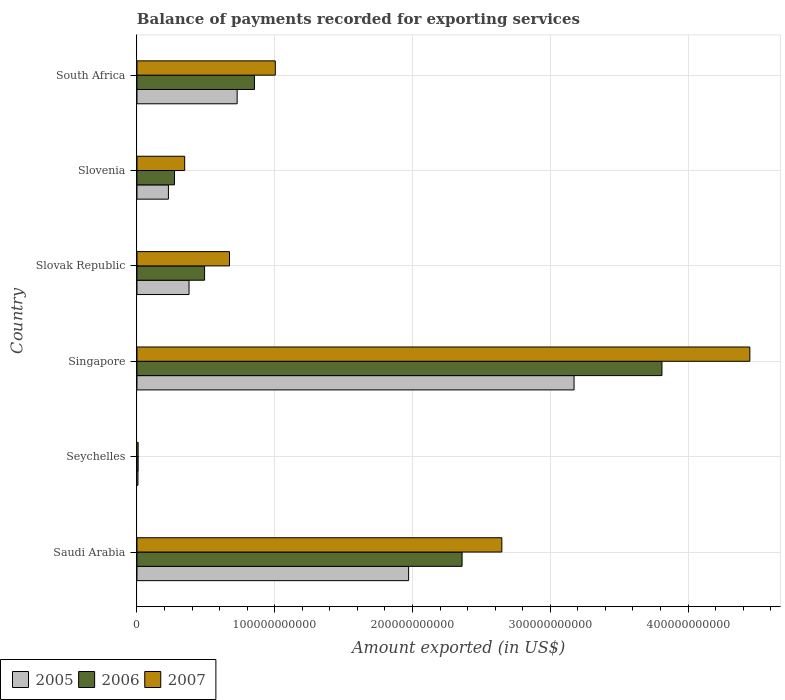How many different coloured bars are there?
Offer a very short reply. 3. How many groups of bars are there?
Keep it short and to the point. 6. How many bars are there on the 5th tick from the bottom?
Provide a short and direct response. 3. What is the label of the 3rd group of bars from the top?
Provide a succinct answer. Slovak Republic. In how many cases, is the number of bars for a given country not equal to the number of legend labels?
Your answer should be compact. 0. What is the amount exported in 2005 in South Africa?
Offer a terse response. 7.27e+1. Across all countries, what is the maximum amount exported in 2006?
Your answer should be compact. 3.81e+11. Across all countries, what is the minimum amount exported in 2005?
Ensure brevity in your answer.  7.29e+08. In which country was the amount exported in 2006 maximum?
Your answer should be compact. Singapore. In which country was the amount exported in 2005 minimum?
Ensure brevity in your answer.  Seychelles. What is the total amount exported in 2006 in the graph?
Offer a terse response. 7.79e+11. What is the difference between the amount exported in 2005 in Seychelles and that in Slovak Republic?
Offer a very short reply. -3.71e+1. What is the difference between the amount exported in 2005 in Saudi Arabia and the amount exported in 2006 in South Africa?
Provide a short and direct response. 1.12e+11. What is the average amount exported in 2006 per country?
Provide a succinct answer. 1.30e+11. What is the difference between the amount exported in 2005 and amount exported in 2007 in Saudi Arabia?
Your answer should be compact. -6.77e+1. What is the ratio of the amount exported in 2005 in Seychelles to that in South Africa?
Provide a short and direct response. 0.01. Is the difference between the amount exported in 2005 in Saudi Arabia and Slovenia greater than the difference between the amount exported in 2007 in Saudi Arabia and Slovenia?
Ensure brevity in your answer.  No. What is the difference between the highest and the second highest amount exported in 2007?
Your response must be concise. 1.80e+11. What is the difference between the highest and the lowest amount exported in 2006?
Provide a short and direct response. 3.80e+11. In how many countries, is the amount exported in 2006 greater than the average amount exported in 2006 taken over all countries?
Ensure brevity in your answer.  2. Is the sum of the amount exported in 2005 in Saudi Arabia and Singapore greater than the maximum amount exported in 2007 across all countries?
Offer a very short reply. Yes. What does the 3rd bar from the top in Slovak Republic represents?
Ensure brevity in your answer.  2005. How many countries are there in the graph?
Your answer should be very brief. 6. What is the difference between two consecutive major ticks on the X-axis?
Provide a succinct answer. 1.00e+11. Are the values on the major ticks of X-axis written in scientific E-notation?
Offer a very short reply. No. Does the graph contain any zero values?
Make the answer very short. No. Does the graph contain grids?
Give a very brief answer. Yes. Where does the legend appear in the graph?
Your response must be concise. Bottom left. How are the legend labels stacked?
Your response must be concise. Horizontal. What is the title of the graph?
Your answer should be compact. Balance of payments recorded for exporting services. Does "2004" appear as one of the legend labels in the graph?
Keep it short and to the point. No. What is the label or title of the X-axis?
Your response must be concise. Amount exported (in US$). What is the label or title of the Y-axis?
Offer a terse response. Country. What is the Amount exported (in US$) in 2005 in Saudi Arabia?
Offer a very short reply. 1.97e+11. What is the Amount exported (in US$) of 2006 in Saudi Arabia?
Your answer should be very brief. 2.36e+11. What is the Amount exported (in US$) of 2007 in Saudi Arabia?
Make the answer very short. 2.65e+11. What is the Amount exported (in US$) in 2005 in Seychelles?
Ensure brevity in your answer.  7.29e+08. What is the Amount exported (in US$) in 2006 in Seychelles?
Ensure brevity in your answer.  8.61e+08. What is the Amount exported (in US$) of 2007 in Seychelles?
Ensure brevity in your answer.  8.57e+08. What is the Amount exported (in US$) of 2005 in Singapore?
Ensure brevity in your answer.  3.17e+11. What is the Amount exported (in US$) of 2006 in Singapore?
Offer a terse response. 3.81e+11. What is the Amount exported (in US$) of 2007 in Singapore?
Make the answer very short. 4.45e+11. What is the Amount exported (in US$) in 2005 in Slovak Republic?
Offer a terse response. 3.78e+1. What is the Amount exported (in US$) in 2006 in Slovak Republic?
Your answer should be compact. 4.91e+1. What is the Amount exported (in US$) of 2007 in Slovak Republic?
Offer a terse response. 6.72e+1. What is the Amount exported (in US$) in 2005 in Slovenia?
Provide a short and direct response. 2.28e+1. What is the Amount exported (in US$) of 2006 in Slovenia?
Your answer should be very brief. 2.72e+1. What is the Amount exported (in US$) of 2007 in Slovenia?
Ensure brevity in your answer.  3.46e+1. What is the Amount exported (in US$) of 2005 in South Africa?
Ensure brevity in your answer.  7.27e+1. What is the Amount exported (in US$) of 2006 in South Africa?
Provide a short and direct response. 8.53e+1. What is the Amount exported (in US$) in 2007 in South Africa?
Your answer should be compact. 1.00e+11. Across all countries, what is the maximum Amount exported (in US$) in 2005?
Make the answer very short. 3.17e+11. Across all countries, what is the maximum Amount exported (in US$) in 2006?
Give a very brief answer. 3.81e+11. Across all countries, what is the maximum Amount exported (in US$) of 2007?
Ensure brevity in your answer.  4.45e+11. Across all countries, what is the minimum Amount exported (in US$) in 2005?
Provide a succinct answer. 7.29e+08. Across all countries, what is the minimum Amount exported (in US$) of 2006?
Your answer should be very brief. 8.61e+08. Across all countries, what is the minimum Amount exported (in US$) in 2007?
Ensure brevity in your answer.  8.57e+08. What is the total Amount exported (in US$) in 2005 in the graph?
Ensure brevity in your answer.  6.49e+11. What is the total Amount exported (in US$) of 2006 in the graph?
Offer a very short reply. 7.79e+11. What is the total Amount exported (in US$) of 2007 in the graph?
Offer a terse response. 9.13e+11. What is the difference between the Amount exported (in US$) in 2005 in Saudi Arabia and that in Seychelles?
Keep it short and to the point. 1.96e+11. What is the difference between the Amount exported (in US$) in 2006 in Saudi Arabia and that in Seychelles?
Offer a very short reply. 2.35e+11. What is the difference between the Amount exported (in US$) in 2007 in Saudi Arabia and that in Seychelles?
Provide a short and direct response. 2.64e+11. What is the difference between the Amount exported (in US$) in 2005 in Saudi Arabia and that in Singapore?
Make the answer very short. -1.20e+11. What is the difference between the Amount exported (in US$) of 2006 in Saudi Arabia and that in Singapore?
Provide a succinct answer. -1.45e+11. What is the difference between the Amount exported (in US$) in 2007 in Saudi Arabia and that in Singapore?
Ensure brevity in your answer.  -1.80e+11. What is the difference between the Amount exported (in US$) of 2005 in Saudi Arabia and that in Slovak Republic?
Offer a terse response. 1.59e+11. What is the difference between the Amount exported (in US$) in 2006 in Saudi Arabia and that in Slovak Republic?
Make the answer very short. 1.87e+11. What is the difference between the Amount exported (in US$) in 2007 in Saudi Arabia and that in Slovak Republic?
Provide a short and direct response. 1.98e+11. What is the difference between the Amount exported (in US$) of 2005 in Saudi Arabia and that in Slovenia?
Ensure brevity in your answer.  1.74e+11. What is the difference between the Amount exported (in US$) of 2006 in Saudi Arabia and that in Slovenia?
Give a very brief answer. 2.09e+11. What is the difference between the Amount exported (in US$) of 2007 in Saudi Arabia and that in Slovenia?
Offer a terse response. 2.30e+11. What is the difference between the Amount exported (in US$) of 2005 in Saudi Arabia and that in South Africa?
Offer a terse response. 1.24e+11. What is the difference between the Amount exported (in US$) in 2006 in Saudi Arabia and that in South Africa?
Keep it short and to the point. 1.51e+11. What is the difference between the Amount exported (in US$) in 2007 in Saudi Arabia and that in South Africa?
Your response must be concise. 1.64e+11. What is the difference between the Amount exported (in US$) in 2005 in Seychelles and that in Singapore?
Keep it short and to the point. -3.17e+11. What is the difference between the Amount exported (in US$) in 2006 in Seychelles and that in Singapore?
Provide a succinct answer. -3.80e+11. What is the difference between the Amount exported (in US$) in 2007 in Seychelles and that in Singapore?
Ensure brevity in your answer.  -4.44e+11. What is the difference between the Amount exported (in US$) of 2005 in Seychelles and that in Slovak Republic?
Ensure brevity in your answer.  -3.71e+1. What is the difference between the Amount exported (in US$) of 2006 in Seychelles and that in Slovak Republic?
Make the answer very short. -4.82e+1. What is the difference between the Amount exported (in US$) in 2007 in Seychelles and that in Slovak Republic?
Your response must be concise. -6.63e+1. What is the difference between the Amount exported (in US$) of 2005 in Seychelles and that in Slovenia?
Offer a very short reply. -2.21e+1. What is the difference between the Amount exported (in US$) of 2006 in Seychelles and that in Slovenia?
Ensure brevity in your answer.  -2.64e+1. What is the difference between the Amount exported (in US$) in 2007 in Seychelles and that in Slovenia?
Make the answer very short. -3.38e+1. What is the difference between the Amount exported (in US$) in 2005 in Seychelles and that in South Africa?
Give a very brief answer. -7.20e+1. What is the difference between the Amount exported (in US$) of 2006 in Seychelles and that in South Africa?
Ensure brevity in your answer.  -8.44e+1. What is the difference between the Amount exported (in US$) of 2007 in Seychelles and that in South Africa?
Ensure brevity in your answer.  -9.96e+1. What is the difference between the Amount exported (in US$) in 2005 in Singapore and that in Slovak Republic?
Ensure brevity in your answer.  2.79e+11. What is the difference between the Amount exported (in US$) of 2006 in Singapore and that in Slovak Republic?
Ensure brevity in your answer.  3.32e+11. What is the difference between the Amount exported (in US$) in 2007 in Singapore and that in Slovak Republic?
Provide a short and direct response. 3.78e+11. What is the difference between the Amount exported (in US$) in 2005 in Singapore and that in Slovenia?
Your response must be concise. 2.94e+11. What is the difference between the Amount exported (in US$) of 2006 in Singapore and that in Slovenia?
Your response must be concise. 3.54e+11. What is the difference between the Amount exported (in US$) in 2007 in Singapore and that in Slovenia?
Your answer should be compact. 4.10e+11. What is the difference between the Amount exported (in US$) in 2005 in Singapore and that in South Africa?
Your answer should be compact. 2.45e+11. What is the difference between the Amount exported (in US$) of 2006 in Singapore and that in South Africa?
Keep it short and to the point. 2.96e+11. What is the difference between the Amount exported (in US$) of 2007 in Singapore and that in South Africa?
Offer a terse response. 3.44e+11. What is the difference between the Amount exported (in US$) in 2005 in Slovak Republic and that in Slovenia?
Provide a short and direct response. 1.50e+1. What is the difference between the Amount exported (in US$) in 2006 in Slovak Republic and that in Slovenia?
Your answer should be very brief. 2.19e+1. What is the difference between the Amount exported (in US$) in 2007 in Slovak Republic and that in Slovenia?
Your response must be concise. 3.25e+1. What is the difference between the Amount exported (in US$) of 2005 in Slovak Republic and that in South Africa?
Provide a succinct answer. -3.49e+1. What is the difference between the Amount exported (in US$) of 2006 in Slovak Republic and that in South Africa?
Provide a short and direct response. -3.62e+1. What is the difference between the Amount exported (in US$) in 2007 in Slovak Republic and that in South Africa?
Give a very brief answer. -3.32e+1. What is the difference between the Amount exported (in US$) of 2005 in Slovenia and that in South Africa?
Your answer should be very brief. -4.99e+1. What is the difference between the Amount exported (in US$) in 2006 in Slovenia and that in South Africa?
Keep it short and to the point. -5.81e+1. What is the difference between the Amount exported (in US$) of 2007 in Slovenia and that in South Africa?
Offer a very short reply. -6.58e+1. What is the difference between the Amount exported (in US$) of 2005 in Saudi Arabia and the Amount exported (in US$) of 2006 in Seychelles?
Ensure brevity in your answer.  1.96e+11. What is the difference between the Amount exported (in US$) of 2005 in Saudi Arabia and the Amount exported (in US$) of 2007 in Seychelles?
Make the answer very short. 1.96e+11. What is the difference between the Amount exported (in US$) of 2006 in Saudi Arabia and the Amount exported (in US$) of 2007 in Seychelles?
Offer a very short reply. 2.35e+11. What is the difference between the Amount exported (in US$) in 2005 in Saudi Arabia and the Amount exported (in US$) in 2006 in Singapore?
Provide a succinct answer. -1.84e+11. What is the difference between the Amount exported (in US$) in 2005 in Saudi Arabia and the Amount exported (in US$) in 2007 in Singapore?
Provide a short and direct response. -2.48e+11. What is the difference between the Amount exported (in US$) of 2006 in Saudi Arabia and the Amount exported (in US$) of 2007 in Singapore?
Offer a terse response. -2.09e+11. What is the difference between the Amount exported (in US$) of 2005 in Saudi Arabia and the Amount exported (in US$) of 2006 in Slovak Republic?
Make the answer very short. 1.48e+11. What is the difference between the Amount exported (in US$) in 2005 in Saudi Arabia and the Amount exported (in US$) in 2007 in Slovak Republic?
Offer a terse response. 1.30e+11. What is the difference between the Amount exported (in US$) of 2006 in Saudi Arabia and the Amount exported (in US$) of 2007 in Slovak Republic?
Ensure brevity in your answer.  1.69e+11. What is the difference between the Amount exported (in US$) of 2005 in Saudi Arabia and the Amount exported (in US$) of 2006 in Slovenia?
Provide a short and direct response. 1.70e+11. What is the difference between the Amount exported (in US$) of 2005 in Saudi Arabia and the Amount exported (in US$) of 2007 in Slovenia?
Your response must be concise. 1.63e+11. What is the difference between the Amount exported (in US$) of 2006 in Saudi Arabia and the Amount exported (in US$) of 2007 in Slovenia?
Offer a very short reply. 2.01e+11. What is the difference between the Amount exported (in US$) of 2005 in Saudi Arabia and the Amount exported (in US$) of 2006 in South Africa?
Offer a terse response. 1.12e+11. What is the difference between the Amount exported (in US$) in 2005 in Saudi Arabia and the Amount exported (in US$) in 2007 in South Africa?
Your response must be concise. 9.68e+1. What is the difference between the Amount exported (in US$) in 2006 in Saudi Arabia and the Amount exported (in US$) in 2007 in South Africa?
Your response must be concise. 1.36e+11. What is the difference between the Amount exported (in US$) of 2005 in Seychelles and the Amount exported (in US$) of 2006 in Singapore?
Your answer should be very brief. -3.80e+11. What is the difference between the Amount exported (in US$) in 2005 in Seychelles and the Amount exported (in US$) in 2007 in Singapore?
Ensure brevity in your answer.  -4.44e+11. What is the difference between the Amount exported (in US$) of 2006 in Seychelles and the Amount exported (in US$) of 2007 in Singapore?
Make the answer very short. -4.44e+11. What is the difference between the Amount exported (in US$) in 2005 in Seychelles and the Amount exported (in US$) in 2006 in Slovak Republic?
Make the answer very short. -4.83e+1. What is the difference between the Amount exported (in US$) in 2005 in Seychelles and the Amount exported (in US$) in 2007 in Slovak Republic?
Provide a short and direct response. -6.64e+1. What is the difference between the Amount exported (in US$) of 2006 in Seychelles and the Amount exported (in US$) of 2007 in Slovak Republic?
Give a very brief answer. -6.63e+1. What is the difference between the Amount exported (in US$) in 2005 in Seychelles and the Amount exported (in US$) in 2006 in Slovenia?
Your answer should be very brief. -2.65e+1. What is the difference between the Amount exported (in US$) in 2005 in Seychelles and the Amount exported (in US$) in 2007 in Slovenia?
Your answer should be compact. -3.39e+1. What is the difference between the Amount exported (in US$) in 2006 in Seychelles and the Amount exported (in US$) in 2007 in Slovenia?
Offer a very short reply. -3.38e+1. What is the difference between the Amount exported (in US$) in 2005 in Seychelles and the Amount exported (in US$) in 2006 in South Africa?
Make the answer very short. -8.46e+1. What is the difference between the Amount exported (in US$) in 2005 in Seychelles and the Amount exported (in US$) in 2007 in South Africa?
Provide a succinct answer. -9.97e+1. What is the difference between the Amount exported (in US$) in 2006 in Seychelles and the Amount exported (in US$) in 2007 in South Africa?
Your response must be concise. -9.96e+1. What is the difference between the Amount exported (in US$) in 2005 in Singapore and the Amount exported (in US$) in 2006 in Slovak Republic?
Your response must be concise. 2.68e+11. What is the difference between the Amount exported (in US$) in 2005 in Singapore and the Amount exported (in US$) in 2007 in Slovak Republic?
Ensure brevity in your answer.  2.50e+11. What is the difference between the Amount exported (in US$) of 2006 in Singapore and the Amount exported (in US$) of 2007 in Slovak Republic?
Offer a very short reply. 3.14e+11. What is the difference between the Amount exported (in US$) of 2005 in Singapore and the Amount exported (in US$) of 2006 in Slovenia?
Offer a very short reply. 2.90e+11. What is the difference between the Amount exported (in US$) of 2005 in Singapore and the Amount exported (in US$) of 2007 in Slovenia?
Make the answer very short. 2.83e+11. What is the difference between the Amount exported (in US$) in 2006 in Singapore and the Amount exported (in US$) in 2007 in Slovenia?
Offer a very short reply. 3.46e+11. What is the difference between the Amount exported (in US$) of 2005 in Singapore and the Amount exported (in US$) of 2006 in South Africa?
Provide a succinct answer. 2.32e+11. What is the difference between the Amount exported (in US$) in 2005 in Singapore and the Amount exported (in US$) in 2007 in South Africa?
Offer a terse response. 2.17e+11. What is the difference between the Amount exported (in US$) of 2006 in Singapore and the Amount exported (in US$) of 2007 in South Africa?
Provide a succinct answer. 2.81e+11. What is the difference between the Amount exported (in US$) in 2005 in Slovak Republic and the Amount exported (in US$) in 2006 in Slovenia?
Your response must be concise. 1.06e+1. What is the difference between the Amount exported (in US$) in 2005 in Slovak Republic and the Amount exported (in US$) in 2007 in Slovenia?
Keep it short and to the point. 3.16e+09. What is the difference between the Amount exported (in US$) in 2006 in Slovak Republic and the Amount exported (in US$) in 2007 in Slovenia?
Offer a terse response. 1.44e+1. What is the difference between the Amount exported (in US$) in 2005 in Slovak Republic and the Amount exported (in US$) in 2006 in South Africa?
Provide a succinct answer. -4.75e+1. What is the difference between the Amount exported (in US$) in 2005 in Slovak Republic and the Amount exported (in US$) in 2007 in South Africa?
Provide a short and direct response. -6.26e+1. What is the difference between the Amount exported (in US$) of 2006 in Slovak Republic and the Amount exported (in US$) of 2007 in South Africa?
Keep it short and to the point. -5.13e+1. What is the difference between the Amount exported (in US$) in 2005 in Slovenia and the Amount exported (in US$) in 2006 in South Africa?
Keep it short and to the point. -6.25e+1. What is the difference between the Amount exported (in US$) of 2005 in Slovenia and the Amount exported (in US$) of 2007 in South Africa?
Provide a short and direct response. -7.76e+1. What is the difference between the Amount exported (in US$) in 2006 in Slovenia and the Amount exported (in US$) in 2007 in South Africa?
Your response must be concise. -7.32e+1. What is the average Amount exported (in US$) in 2005 per country?
Give a very brief answer. 1.08e+11. What is the average Amount exported (in US$) of 2006 per country?
Your response must be concise. 1.30e+11. What is the average Amount exported (in US$) of 2007 per country?
Your answer should be compact. 1.52e+11. What is the difference between the Amount exported (in US$) of 2005 and Amount exported (in US$) of 2006 in Saudi Arabia?
Offer a very short reply. -3.88e+1. What is the difference between the Amount exported (in US$) of 2005 and Amount exported (in US$) of 2007 in Saudi Arabia?
Offer a terse response. -6.77e+1. What is the difference between the Amount exported (in US$) of 2006 and Amount exported (in US$) of 2007 in Saudi Arabia?
Make the answer very short. -2.89e+1. What is the difference between the Amount exported (in US$) of 2005 and Amount exported (in US$) of 2006 in Seychelles?
Your answer should be compact. -1.31e+08. What is the difference between the Amount exported (in US$) of 2005 and Amount exported (in US$) of 2007 in Seychelles?
Ensure brevity in your answer.  -1.28e+08. What is the difference between the Amount exported (in US$) in 2006 and Amount exported (in US$) in 2007 in Seychelles?
Keep it short and to the point. 3.32e+06. What is the difference between the Amount exported (in US$) in 2005 and Amount exported (in US$) in 2006 in Singapore?
Ensure brevity in your answer.  -6.38e+1. What is the difference between the Amount exported (in US$) in 2005 and Amount exported (in US$) in 2007 in Singapore?
Keep it short and to the point. -1.28e+11. What is the difference between the Amount exported (in US$) in 2006 and Amount exported (in US$) in 2007 in Singapore?
Give a very brief answer. -6.38e+1. What is the difference between the Amount exported (in US$) of 2005 and Amount exported (in US$) of 2006 in Slovak Republic?
Keep it short and to the point. -1.13e+1. What is the difference between the Amount exported (in US$) of 2005 and Amount exported (in US$) of 2007 in Slovak Republic?
Offer a very short reply. -2.94e+1. What is the difference between the Amount exported (in US$) of 2006 and Amount exported (in US$) of 2007 in Slovak Republic?
Make the answer very short. -1.81e+1. What is the difference between the Amount exported (in US$) of 2005 and Amount exported (in US$) of 2006 in Slovenia?
Provide a succinct answer. -4.39e+09. What is the difference between the Amount exported (in US$) of 2005 and Amount exported (in US$) of 2007 in Slovenia?
Offer a terse response. -1.18e+1. What is the difference between the Amount exported (in US$) in 2006 and Amount exported (in US$) in 2007 in Slovenia?
Keep it short and to the point. -7.42e+09. What is the difference between the Amount exported (in US$) of 2005 and Amount exported (in US$) of 2006 in South Africa?
Your response must be concise. -1.26e+1. What is the difference between the Amount exported (in US$) of 2005 and Amount exported (in US$) of 2007 in South Africa?
Keep it short and to the point. -2.77e+1. What is the difference between the Amount exported (in US$) in 2006 and Amount exported (in US$) in 2007 in South Africa?
Offer a very short reply. -1.51e+1. What is the ratio of the Amount exported (in US$) of 2005 in Saudi Arabia to that in Seychelles?
Provide a succinct answer. 270.3. What is the ratio of the Amount exported (in US$) of 2006 in Saudi Arabia to that in Seychelles?
Give a very brief answer. 274.2. What is the ratio of the Amount exported (in US$) in 2007 in Saudi Arabia to that in Seychelles?
Provide a short and direct response. 308.93. What is the ratio of the Amount exported (in US$) in 2005 in Saudi Arabia to that in Singapore?
Your answer should be very brief. 0.62. What is the ratio of the Amount exported (in US$) in 2006 in Saudi Arabia to that in Singapore?
Give a very brief answer. 0.62. What is the ratio of the Amount exported (in US$) of 2007 in Saudi Arabia to that in Singapore?
Your answer should be compact. 0.6. What is the ratio of the Amount exported (in US$) in 2005 in Saudi Arabia to that in Slovak Republic?
Give a very brief answer. 5.22. What is the ratio of the Amount exported (in US$) of 2006 in Saudi Arabia to that in Slovak Republic?
Your answer should be very brief. 4.81. What is the ratio of the Amount exported (in US$) in 2007 in Saudi Arabia to that in Slovak Republic?
Make the answer very short. 3.94. What is the ratio of the Amount exported (in US$) in 2005 in Saudi Arabia to that in Slovenia?
Your response must be concise. 8.64. What is the ratio of the Amount exported (in US$) of 2006 in Saudi Arabia to that in Slovenia?
Offer a terse response. 8.67. What is the ratio of the Amount exported (in US$) of 2007 in Saudi Arabia to that in Slovenia?
Your response must be concise. 7.65. What is the ratio of the Amount exported (in US$) of 2005 in Saudi Arabia to that in South Africa?
Make the answer very short. 2.71. What is the ratio of the Amount exported (in US$) of 2006 in Saudi Arabia to that in South Africa?
Offer a very short reply. 2.77. What is the ratio of the Amount exported (in US$) of 2007 in Saudi Arabia to that in South Africa?
Offer a very short reply. 2.64. What is the ratio of the Amount exported (in US$) in 2005 in Seychelles to that in Singapore?
Give a very brief answer. 0. What is the ratio of the Amount exported (in US$) of 2006 in Seychelles to that in Singapore?
Ensure brevity in your answer.  0. What is the ratio of the Amount exported (in US$) of 2007 in Seychelles to that in Singapore?
Offer a very short reply. 0. What is the ratio of the Amount exported (in US$) of 2005 in Seychelles to that in Slovak Republic?
Provide a succinct answer. 0.02. What is the ratio of the Amount exported (in US$) in 2006 in Seychelles to that in Slovak Republic?
Provide a short and direct response. 0.02. What is the ratio of the Amount exported (in US$) of 2007 in Seychelles to that in Slovak Republic?
Ensure brevity in your answer.  0.01. What is the ratio of the Amount exported (in US$) in 2005 in Seychelles to that in Slovenia?
Offer a very short reply. 0.03. What is the ratio of the Amount exported (in US$) of 2006 in Seychelles to that in Slovenia?
Offer a terse response. 0.03. What is the ratio of the Amount exported (in US$) of 2007 in Seychelles to that in Slovenia?
Keep it short and to the point. 0.02. What is the ratio of the Amount exported (in US$) of 2005 in Seychelles to that in South Africa?
Provide a succinct answer. 0.01. What is the ratio of the Amount exported (in US$) of 2006 in Seychelles to that in South Africa?
Your answer should be compact. 0.01. What is the ratio of the Amount exported (in US$) in 2007 in Seychelles to that in South Africa?
Keep it short and to the point. 0.01. What is the ratio of the Amount exported (in US$) in 2005 in Singapore to that in Slovak Republic?
Offer a very short reply. 8.39. What is the ratio of the Amount exported (in US$) of 2006 in Singapore to that in Slovak Republic?
Offer a terse response. 7.76. What is the ratio of the Amount exported (in US$) of 2007 in Singapore to that in Slovak Republic?
Offer a terse response. 6.62. What is the ratio of the Amount exported (in US$) of 2005 in Singapore to that in Slovenia?
Ensure brevity in your answer.  13.9. What is the ratio of the Amount exported (in US$) of 2006 in Singapore to that in Slovenia?
Your response must be concise. 14. What is the ratio of the Amount exported (in US$) of 2007 in Singapore to that in Slovenia?
Your answer should be compact. 12.84. What is the ratio of the Amount exported (in US$) in 2005 in Singapore to that in South Africa?
Your response must be concise. 4.36. What is the ratio of the Amount exported (in US$) of 2006 in Singapore to that in South Africa?
Make the answer very short. 4.47. What is the ratio of the Amount exported (in US$) in 2007 in Singapore to that in South Africa?
Provide a succinct answer. 4.43. What is the ratio of the Amount exported (in US$) in 2005 in Slovak Republic to that in Slovenia?
Your answer should be very brief. 1.66. What is the ratio of the Amount exported (in US$) of 2006 in Slovak Republic to that in Slovenia?
Provide a succinct answer. 1.8. What is the ratio of the Amount exported (in US$) of 2007 in Slovak Republic to that in Slovenia?
Your answer should be very brief. 1.94. What is the ratio of the Amount exported (in US$) of 2005 in Slovak Republic to that in South Africa?
Your answer should be compact. 0.52. What is the ratio of the Amount exported (in US$) in 2006 in Slovak Republic to that in South Africa?
Provide a short and direct response. 0.58. What is the ratio of the Amount exported (in US$) in 2007 in Slovak Republic to that in South Africa?
Offer a very short reply. 0.67. What is the ratio of the Amount exported (in US$) in 2005 in Slovenia to that in South Africa?
Offer a terse response. 0.31. What is the ratio of the Amount exported (in US$) in 2006 in Slovenia to that in South Africa?
Keep it short and to the point. 0.32. What is the ratio of the Amount exported (in US$) in 2007 in Slovenia to that in South Africa?
Offer a very short reply. 0.34. What is the difference between the highest and the second highest Amount exported (in US$) in 2005?
Keep it short and to the point. 1.20e+11. What is the difference between the highest and the second highest Amount exported (in US$) of 2006?
Your answer should be very brief. 1.45e+11. What is the difference between the highest and the second highest Amount exported (in US$) of 2007?
Your answer should be very brief. 1.80e+11. What is the difference between the highest and the lowest Amount exported (in US$) in 2005?
Ensure brevity in your answer.  3.17e+11. What is the difference between the highest and the lowest Amount exported (in US$) of 2006?
Your answer should be very brief. 3.80e+11. What is the difference between the highest and the lowest Amount exported (in US$) of 2007?
Provide a short and direct response. 4.44e+11. 